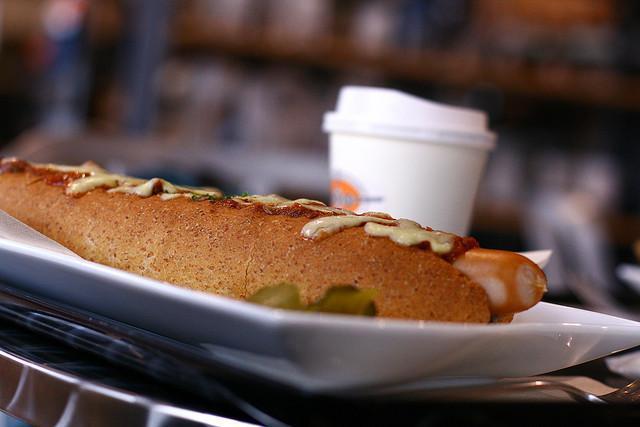How many pickles?
Give a very brief answer. 2. 